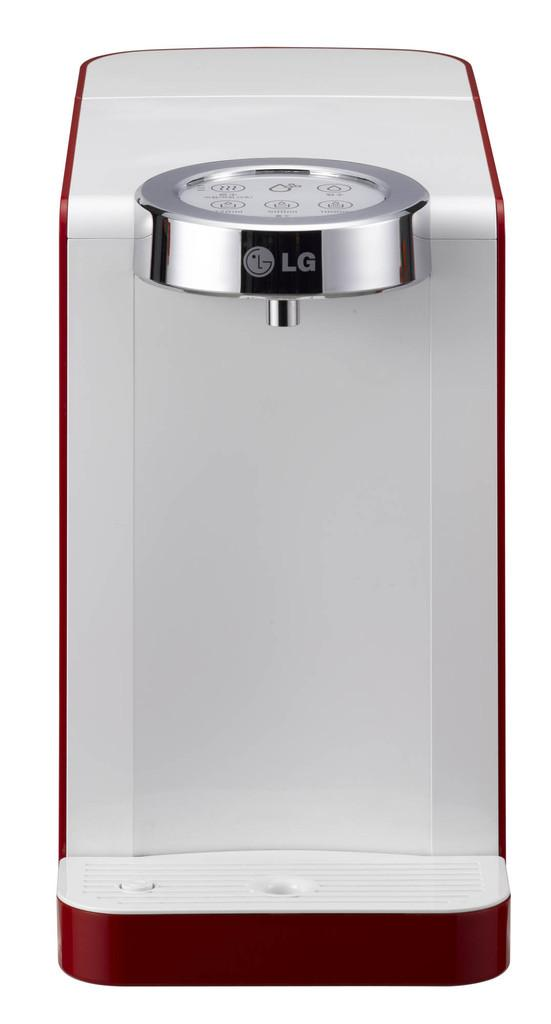<image>
Describe the image concisely. a white and red appliance with a silver piece that says LG on it is sitting in front of a white background 